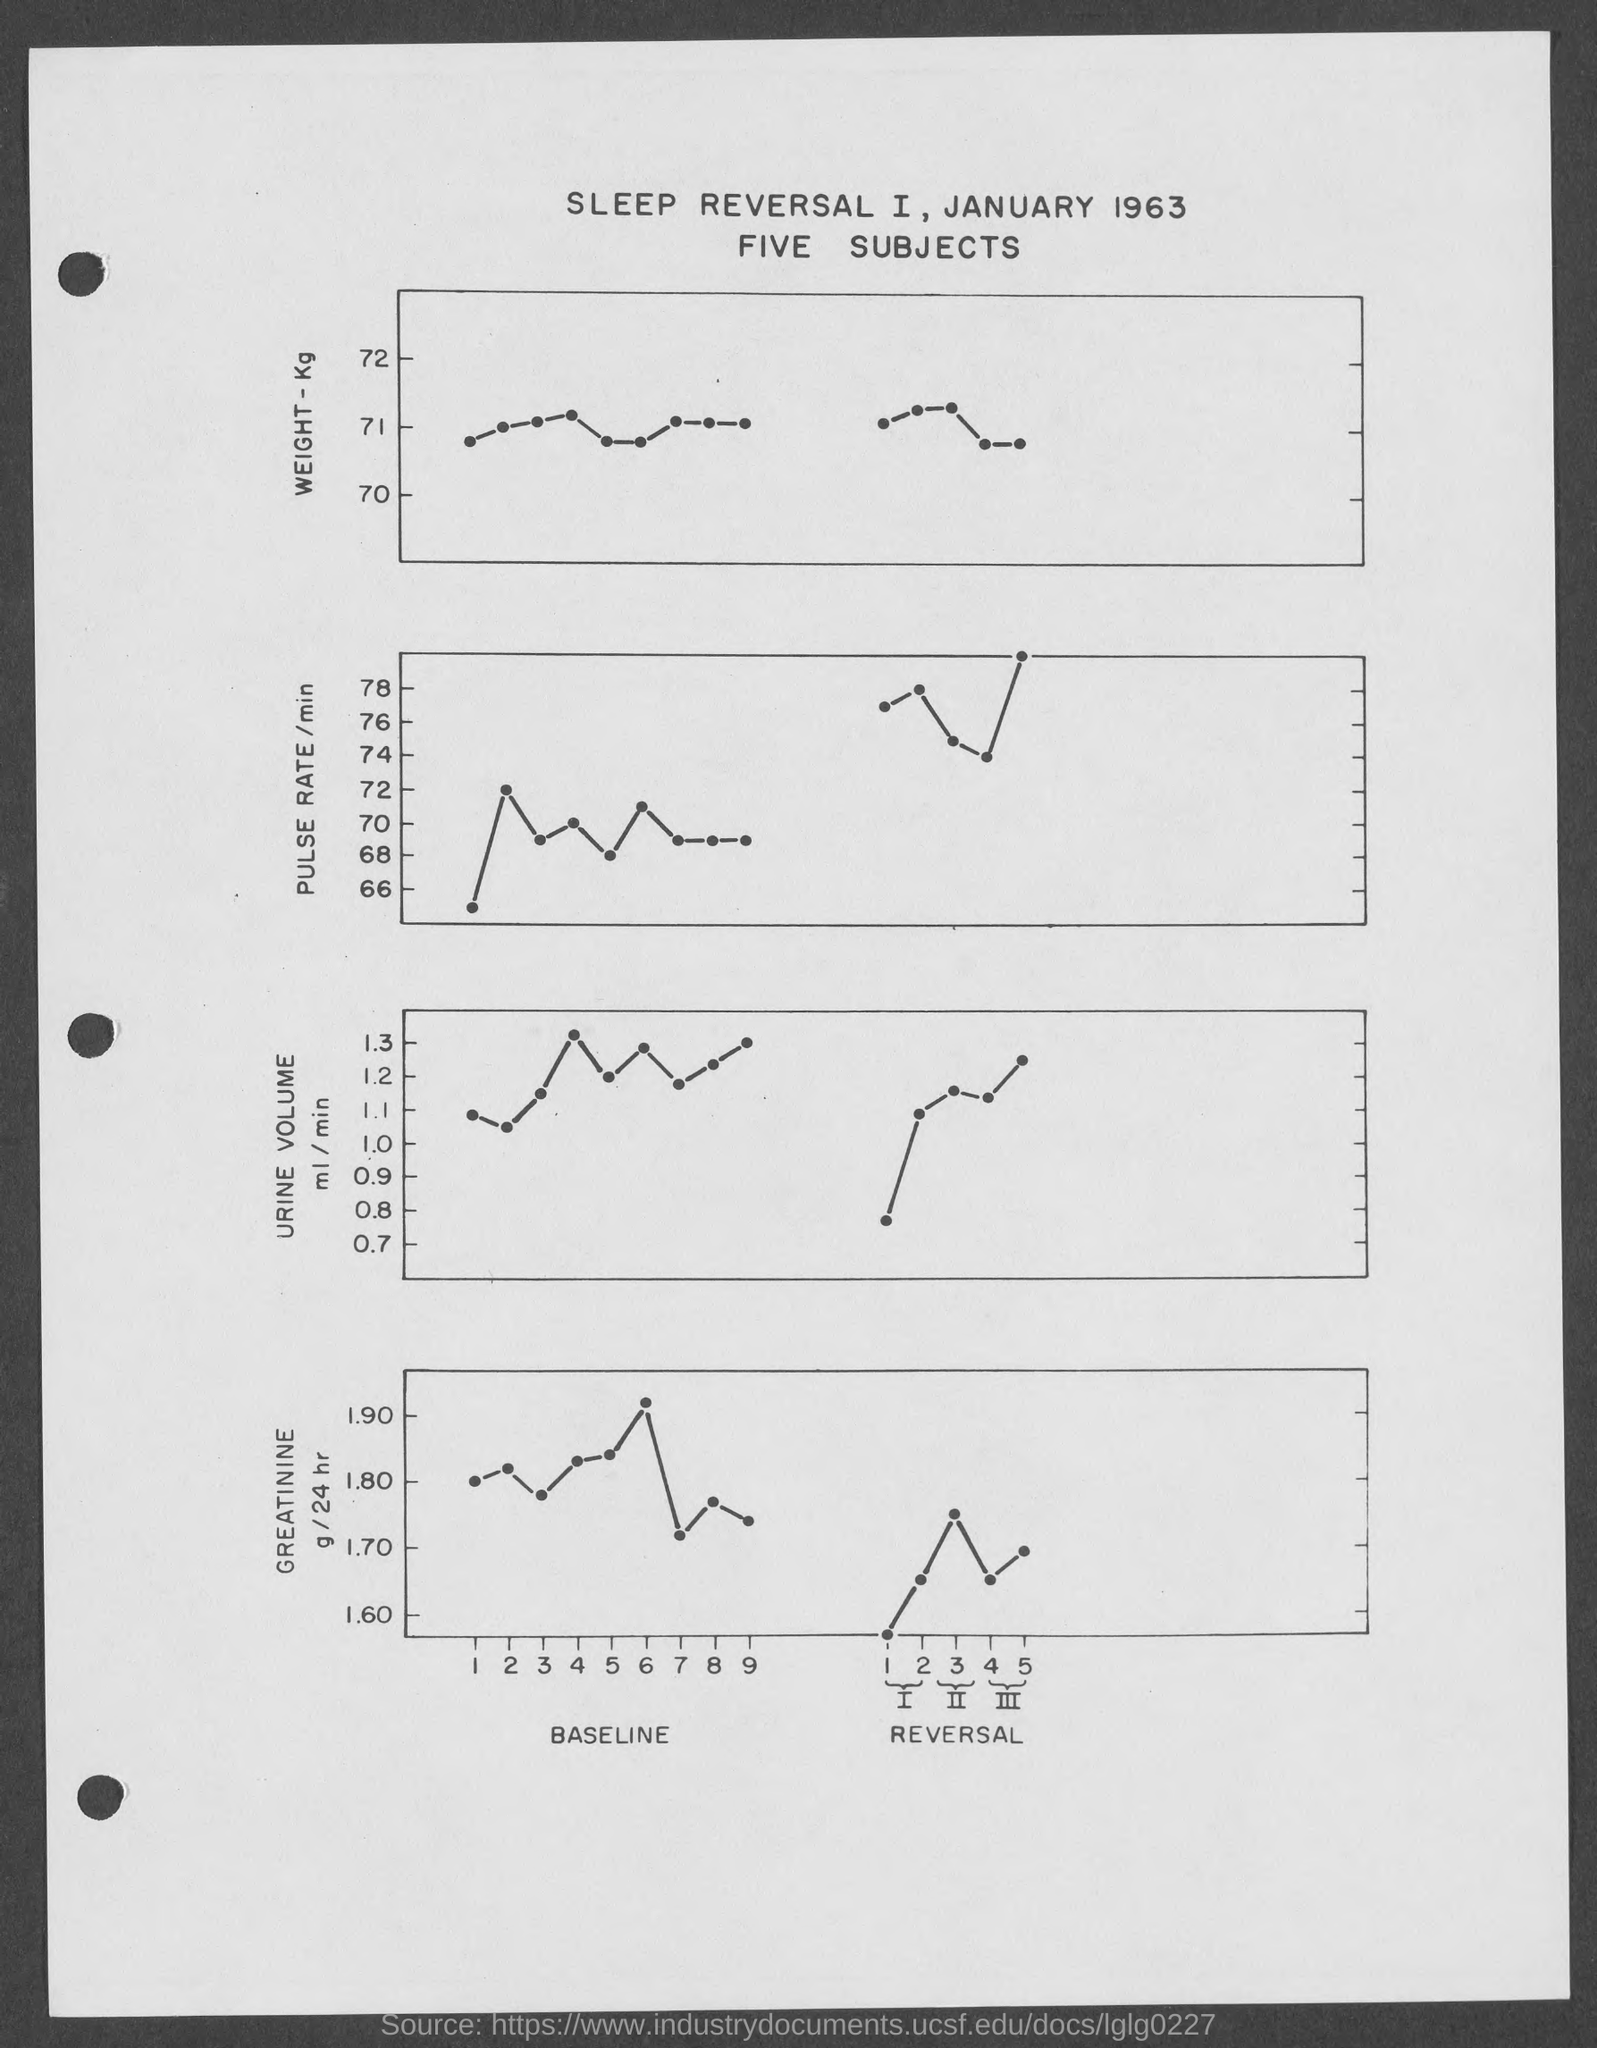Highlight a few significant elements in this photo. The year mentioned in the title is 1963. The attribute plotted along the y-axis of the second graph is pulse rate per minute. 